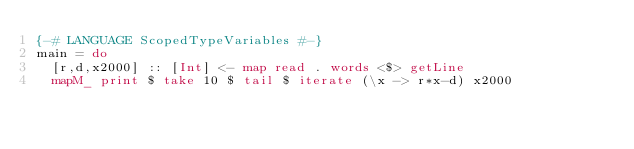<code> <loc_0><loc_0><loc_500><loc_500><_Haskell_>{-# LANGUAGE ScopedTypeVariables #-}
main = do
  [r,d,x2000] :: [Int] <- map read . words <$> getLine
  mapM_ print $ take 10 $ tail $ iterate (\x -> r*x-d) x2000
</code> 